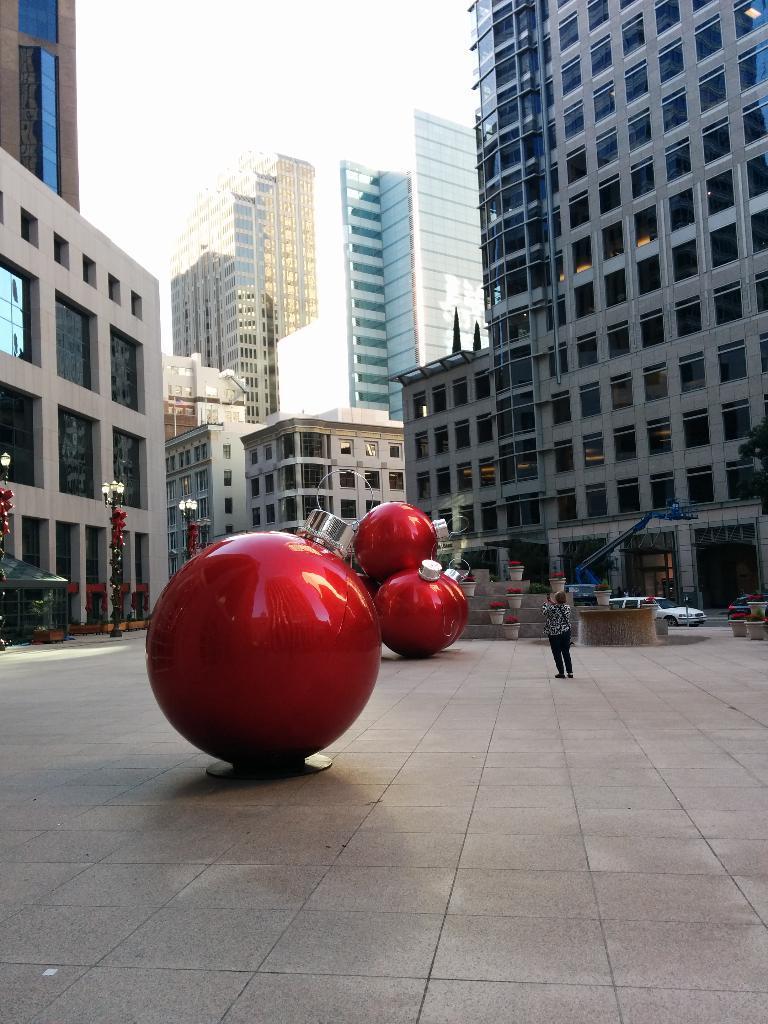Could you give a brief overview of what you see in this image? In this image I can see few buildings, windows, light poles, flower pots, vehicles, one person and the sky. I can see few red and silver color objects on the road. 